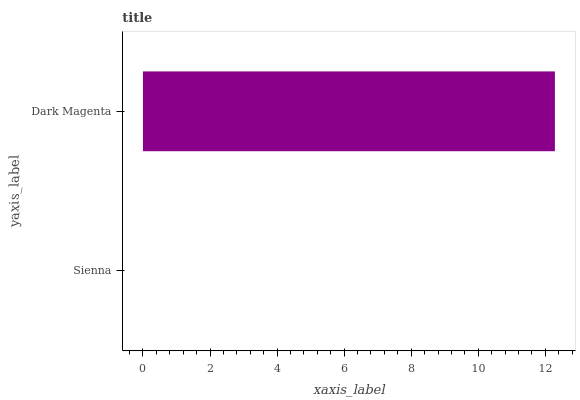Is Sienna the minimum?
Answer yes or no. Yes. Is Dark Magenta the maximum?
Answer yes or no. Yes. Is Dark Magenta the minimum?
Answer yes or no. No. Is Dark Magenta greater than Sienna?
Answer yes or no. Yes. Is Sienna less than Dark Magenta?
Answer yes or no. Yes. Is Sienna greater than Dark Magenta?
Answer yes or no. No. Is Dark Magenta less than Sienna?
Answer yes or no. No. Is Dark Magenta the high median?
Answer yes or no. Yes. Is Sienna the low median?
Answer yes or no. Yes. Is Sienna the high median?
Answer yes or no. No. Is Dark Magenta the low median?
Answer yes or no. No. 